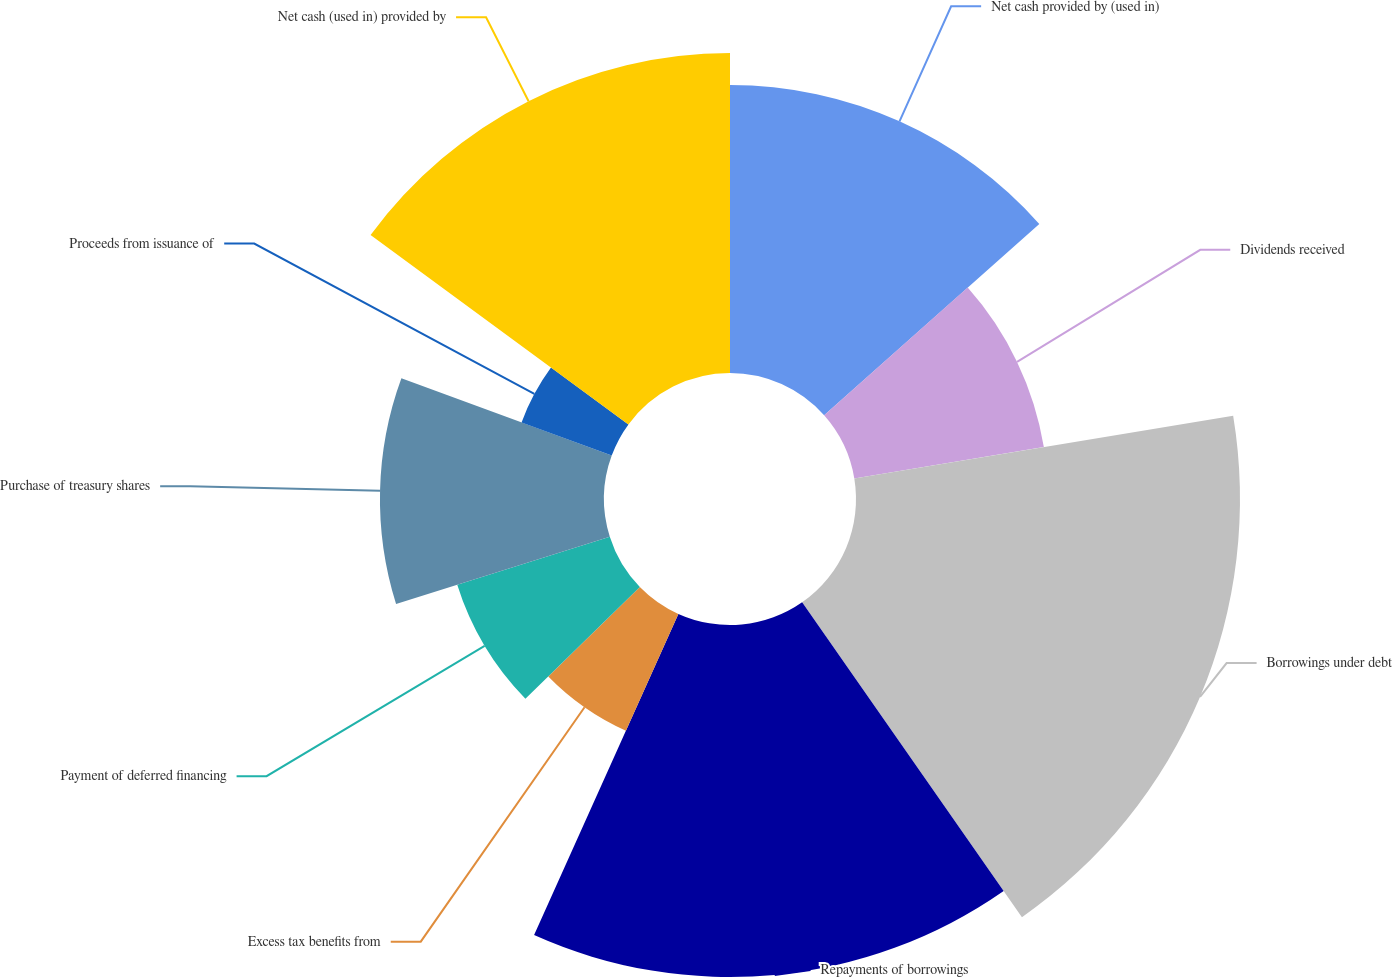Convert chart to OTSL. <chart><loc_0><loc_0><loc_500><loc_500><pie_chart><fcel>Net cash provided by (used in)<fcel>Dividends received<fcel>Borrowings under debt<fcel>Repayments of borrowings<fcel>Excess tax benefits from<fcel>Payment of deferred financing<fcel>Purchase of treasury shares<fcel>Proceeds from issuance of<fcel>Net cash (used in) provided by<nl><fcel>13.43%<fcel>8.96%<fcel>17.91%<fcel>16.42%<fcel>5.97%<fcel>7.46%<fcel>10.45%<fcel>4.48%<fcel>14.92%<nl></chart> 